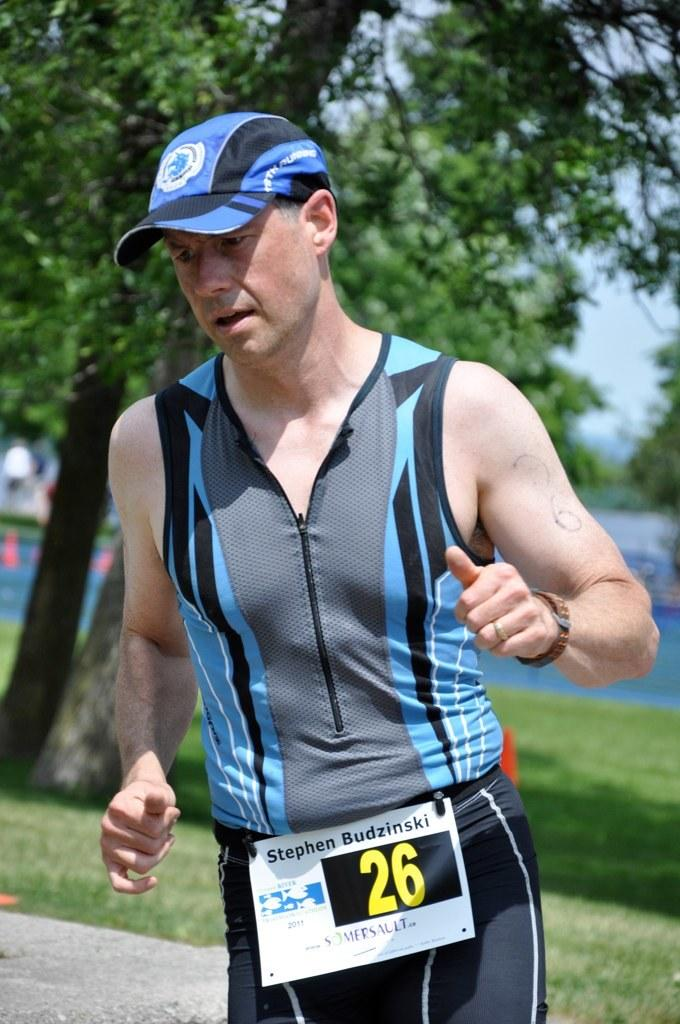What is the main subject in the foreground of the picture? There is a person in the foreground of the picture. What can be seen in the background of the picture? There are trees, grass, and other objects in the background of the picture. What type of bubble can be seen floating near the person in the picture? There is no bubble present in the picture; it only features a person in the foreground and various objects in the background. 